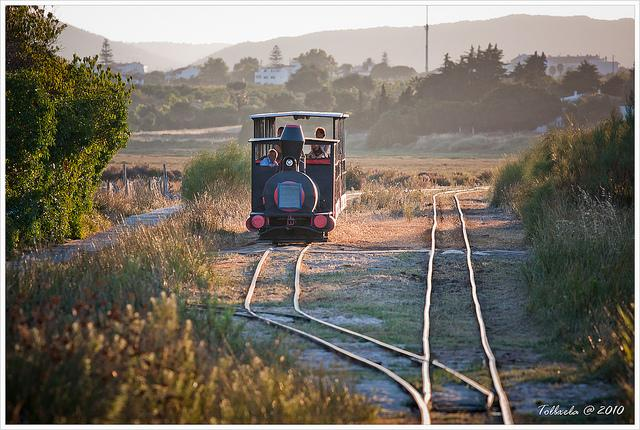How far will this train travel usually? Please explain your reasoning. local only. It is a small train without full cover and it's for people to ride in 